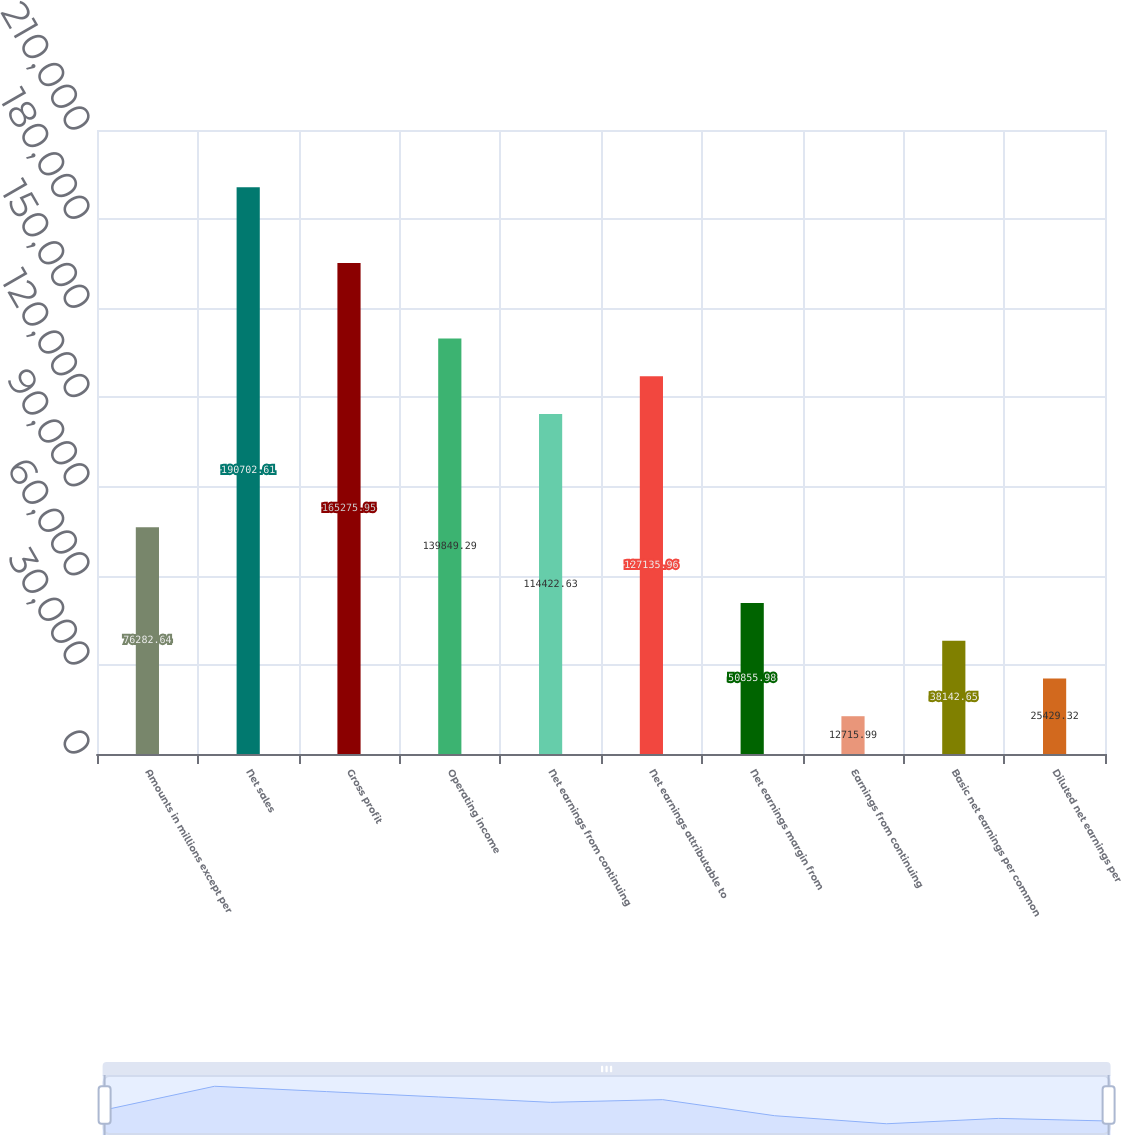Convert chart to OTSL. <chart><loc_0><loc_0><loc_500><loc_500><bar_chart><fcel>Amounts in millions except per<fcel>Net sales<fcel>Gross profit<fcel>Operating income<fcel>Net earnings from continuing<fcel>Net earnings attributable to<fcel>Net earnings margin from<fcel>Earnings from continuing<fcel>Basic net earnings per common<fcel>Diluted net earnings per<nl><fcel>76282.6<fcel>190703<fcel>165276<fcel>139849<fcel>114423<fcel>127136<fcel>50856<fcel>12716<fcel>38142.7<fcel>25429.3<nl></chart> 